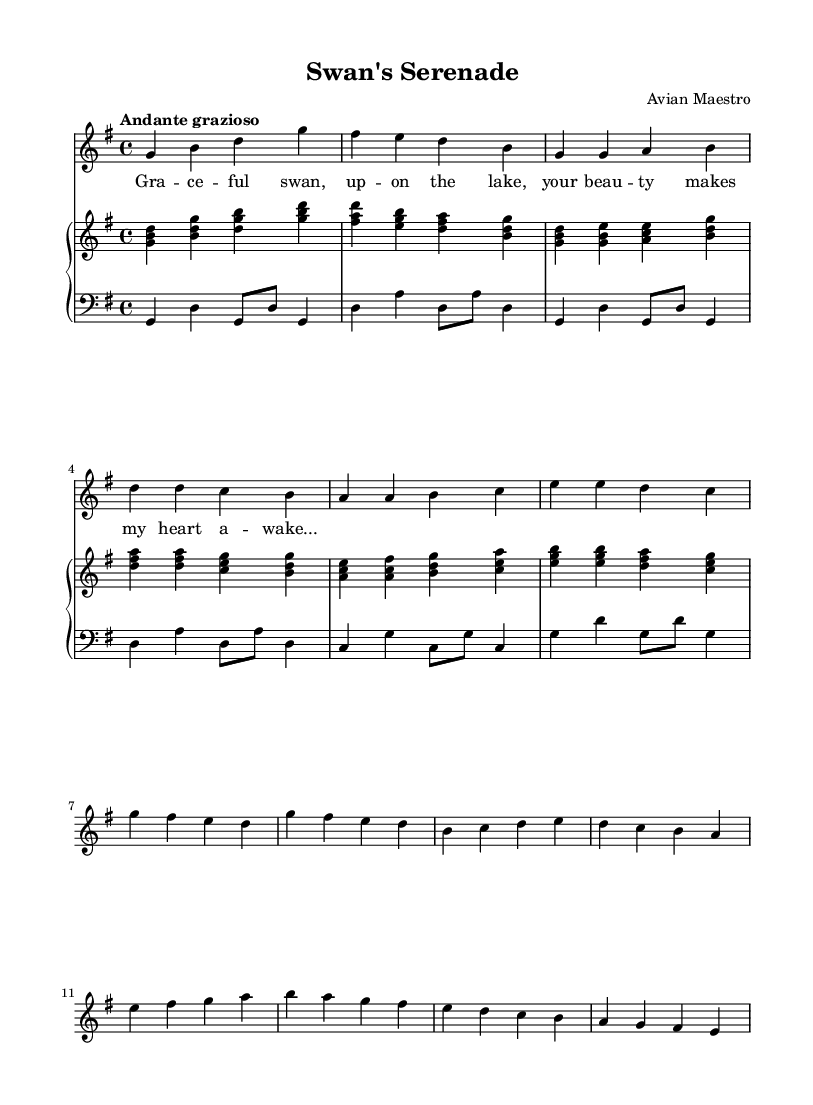What is the key signature of this music? The key signature is G major, which has one sharp (F#). This is derived from the global definition in the LilyPond code where it states `\key g \major`.
Answer: G major What is the time signature of this music? The time signature is 4/4, which indicates four beats per measure. This can be found in the global definition in the LilyPond code where it states `\time 4/4`.
Answer: 4/4 What is the tempo marking for this piece? The tempo marking is "Andante grazioso," which means a moderately slow and graceful style. This is stated in the global definition section of the code where it specifies the tempo.
Answer: Andante grazioso How many measures are present in the first verse along with the chorus? There are eight measures in total: four measures in the verse and four in the chorus. The verse is identified as the section before the Chorus, and each section is divided into four measures.
Answer: Eight What is the dynamic marking for the soprano part? The dynamic marking for the soprano part is `\dynamicUp`, which suggests that the soprano line should be played loudly or emphasized. This is specified right after defining the soprano relative in the code.
Answer: Up What musical form does the piece follow based on its layout? The piece follows a verse-chorus structure, as indicated by distinct sections labeled as "Verse 1" and "Chorus" within the musical content. This means it has a repeating pattern, typical in romantic compositions celebrating themes like grace and beauty.
Answer: Verse-chorus 